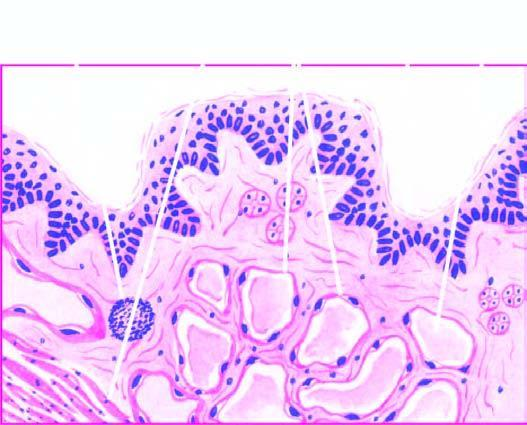does stroma show scattered collection of lymphocytes?
Answer the question using a single word or phrase. Yes 